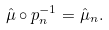<formula> <loc_0><loc_0><loc_500><loc_500>\hat { \mu } \circ p _ { n } ^ { - 1 } = \hat { \mu } _ { n } .</formula> 